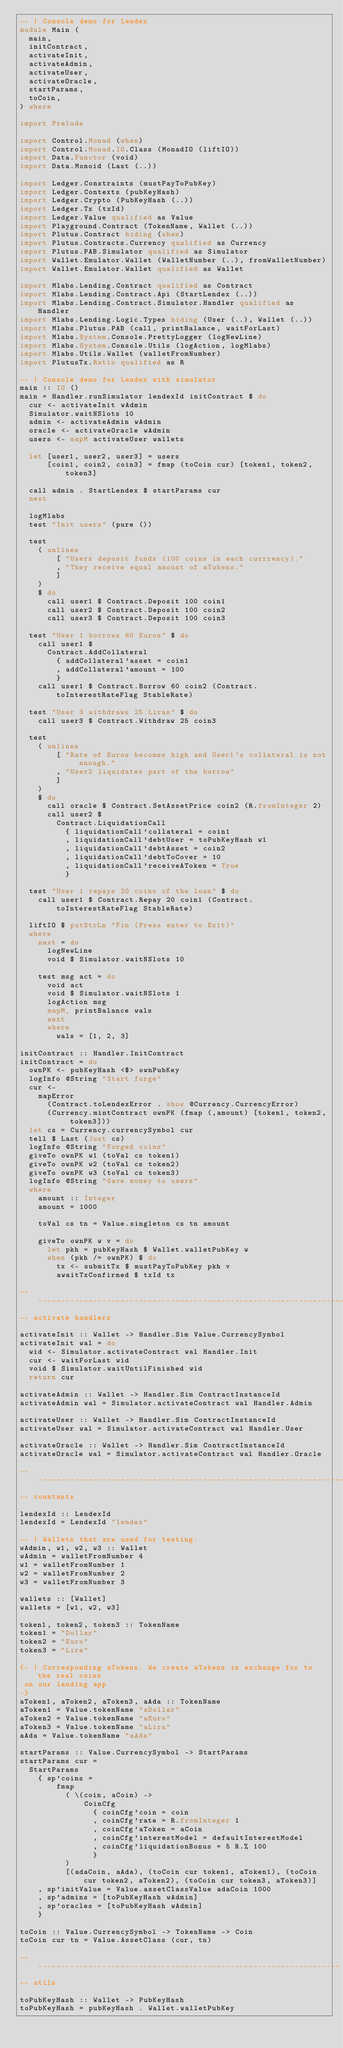<code> <loc_0><loc_0><loc_500><loc_500><_Haskell_>-- | Console demo for Lendex
module Main (
  main,
  initContract,
  activateInit,
  activateAdmin,
  activateUser,
  activateOracle,
  startParams,
  toCoin,
) where

import Prelude

import Control.Monad (when)
import Control.Monad.IO.Class (MonadIO (liftIO))
import Data.Functor (void)
import Data.Monoid (Last (..))

import Ledger.Constraints (mustPayToPubKey)
import Ledger.Contexts (pubKeyHash)
import Ledger.Crypto (PubKeyHash (..))
import Ledger.Tx (txId)
import Ledger.Value qualified as Value
import Playground.Contract (TokenName, Wallet (..))
import Plutus.Contract hiding (when)
import Plutus.Contracts.Currency qualified as Currency
import Plutus.PAB.Simulator qualified as Simulator
import Wallet.Emulator.Wallet (WalletNumber (..), fromWalletNumber)
import Wallet.Emulator.Wallet qualified as Wallet

import Mlabs.Lending.Contract qualified as Contract
import Mlabs.Lending.Contract.Api (StartLendex (..))
import Mlabs.Lending.Contract.Simulator.Handler qualified as Handler
import Mlabs.Lending.Logic.Types hiding (User (..), Wallet (..))
import Mlabs.Plutus.PAB (call, printBalance, waitForLast)
import Mlabs.System.Console.PrettyLogger (logNewLine)
import Mlabs.System.Console.Utils (logAction, logMlabs)
import Mlabs.Utils.Wallet (walletFromNumber)
import PlutusTx.Ratio qualified as R

-- | Console demo for Lendex with simulator
main :: IO ()
main = Handler.runSimulator lendexId initContract $ do
  cur <- activateInit wAdmin
  Simulator.waitNSlots 10
  admin <- activateAdmin wAdmin
  oracle <- activateOracle wAdmin
  users <- mapM activateUser wallets

  let [user1, user2, user3] = users
      [coin1, coin2, coin3] = fmap (toCoin cur) [token1, token2, token3]

  call admin . StartLendex $ startParams cur
  next

  logMlabs
  test "Init users" (pure ())

  test
    ( unlines
        [ "Users deposit funds (100 coins in each currrency)."
        , "They receive equal amount of aTokens."
        ]
    )
    $ do
      call user1 $ Contract.Deposit 100 coin1
      call user2 $ Contract.Deposit 100 coin2
      call user3 $ Contract.Deposit 100 coin3

  test "User 1 borrows 60 Euros" $ do
    call user1 $
      Contract.AddCollateral
        { addCollateral'asset = coin1
        , addCollateral'amount = 100
        }
    call user1 $ Contract.Borrow 60 coin2 (Contract.toInterestRateFlag StableRate)

  test "User 3 withdraws 25 Liras" $ do
    call user3 $ Contract.Withdraw 25 coin3

  test
    ( unlines
        [ "Rate of Euros becomes high and User1's collateral is not enough."
        , "User2 liquidates part of the borrow"
        ]
    )
    $ do
      call oracle $ Contract.SetAssetPrice coin2 (R.fromInteger 2)
      call user2 $
        Contract.LiquidationCall
          { liquidationCall'collateral = coin1
          , liquidationCall'debtUser = toPubKeyHash w1
          , liquidationCall'debtAsset = coin2
          , liquidationCall'debtToCover = 10
          , liquidationCall'receiveAToken = True
          }

  test "User 1 repays 20 coins of the loan" $ do
    call user1 $ Contract.Repay 20 coin1 (Contract.toInterestRateFlag StableRate)

  liftIO $ putStrLn "Fin (Press enter to Exit)"
  where
    next = do
      logNewLine
      void $ Simulator.waitNSlots 10

    test msg act = do
      void act
      void $ Simulator.waitNSlots 1
      logAction msg
      mapM_ printBalance wals
      next
      where
        wals = [1, 2, 3]

initContract :: Handler.InitContract
initContract = do
  ownPK <- pubKeyHash <$> ownPubKey
  logInfo @String "Start forge"
  cur <-
    mapError
      (Contract.toLendexError . show @Currency.CurrencyError)
      (Currency.mintContract ownPK (fmap (,amount) [token1, token2, token3]))
  let cs = Currency.currencySymbol cur
  tell $ Last (Just cs)
  logInfo @String "Forged coins"
  giveTo ownPK w1 (toVal cs token1)
  giveTo ownPK w2 (toVal cs token2)
  giveTo ownPK w3 (toVal cs token3)
  logInfo @String "Gave money to users"
  where
    amount :: Integer
    amount = 1000

    toVal cs tn = Value.singleton cs tn amount

    giveTo ownPK w v = do
      let pkh = pubKeyHash $ Wallet.walletPubKey w
      when (pkh /= ownPK) $ do
        tx <- submitTx $ mustPayToPubKey pkh v
        awaitTxConfirmed $ txId tx

-----------------------------------------------------------------------
-- activate handlers

activateInit :: Wallet -> Handler.Sim Value.CurrencySymbol
activateInit wal = do
  wid <- Simulator.activateContract wal Handler.Init
  cur <- waitForLast wid
  void $ Simulator.waitUntilFinished wid
  return cur

activateAdmin :: Wallet -> Handler.Sim ContractInstanceId
activateAdmin wal = Simulator.activateContract wal Handler.Admin

activateUser :: Wallet -> Handler.Sim ContractInstanceId
activateUser wal = Simulator.activateContract wal Handler.User

activateOracle :: Wallet -> Handler.Sim ContractInstanceId
activateOracle wal = Simulator.activateContract wal Handler.Oracle

-----------------------------------------------------------------------
-- constants

lendexId :: LendexId
lendexId = LendexId "lendex"

-- | Wallets that are used for testing.
wAdmin, w1, w2, w3 :: Wallet
wAdmin = walletFromNumber 4
w1 = walletFromNumber 1
w2 = walletFromNumber 2
w3 = walletFromNumber 3

wallets :: [Wallet]
wallets = [w1, w2, w3]

token1, token2, token3 :: TokenName
token1 = "Dollar"
token2 = "Euro"
token3 = "Lira"

{- | Corresponding aTokens. We create aTokens in exchange for to the real coins
 on our lending app
-}
aToken1, aToken2, aToken3, aAda :: TokenName
aToken1 = Value.tokenName "aDollar"
aToken2 = Value.tokenName "aEuro"
aToken3 = Value.tokenName "aLira"
aAda = Value.tokenName "aAda"

startParams :: Value.CurrencySymbol -> StartParams
startParams cur =
  StartParams
    { sp'coins =
        fmap
          ( \(coin, aCoin) ->
              CoinCfg
                { coinCfg'coin = coin
                , coinCfg'rate = R.fromInteger 1
                , coinCfg'aToken = aCoin
                , coinCfg'interestModel = defaultInterestModel
                , coinCfg'liquidationBonus = 5 R.% 100
                }
          )
          [(adaCoin, aAda), (toCoin cur token1, aToken1), (toCoin cur token2, aToken2), (toCoin cur token3, aToken3)]
    , sp'initValue = Value.assetClassValue adaCoin 1000
    , sp'admins = [toPubKeyHash wAdmin]
    , sp'oracles = [toPubKeyHash wAdmin]
    }

toCoin :: Value.CurrencySymbol -> TokenName -> Coin
toCoin cur tn = Value.AssetClass (cur, tn)

--------------------------------------------------------------------
-- utils

toPubKeyHash :: Wallet -> PubKeyHash
toPubKeyHash = pubKeyHash . Wallet.walletPubKey
</code> 